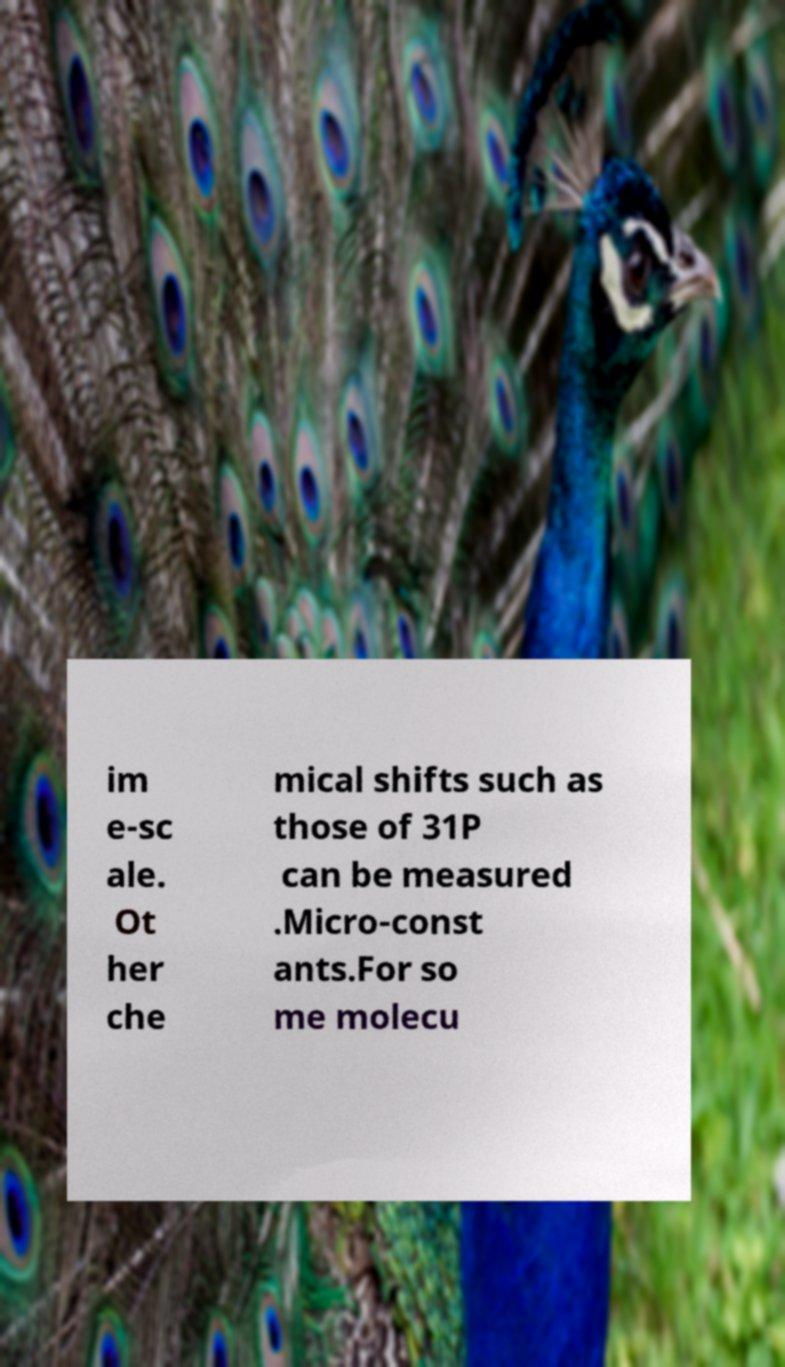Could you assist in decoding the text presented in this image and type it out clearly? im e-sc ale. Ot her che mical shifts such as those of 31P can be measured .Micro-const ants.For so me molecu 